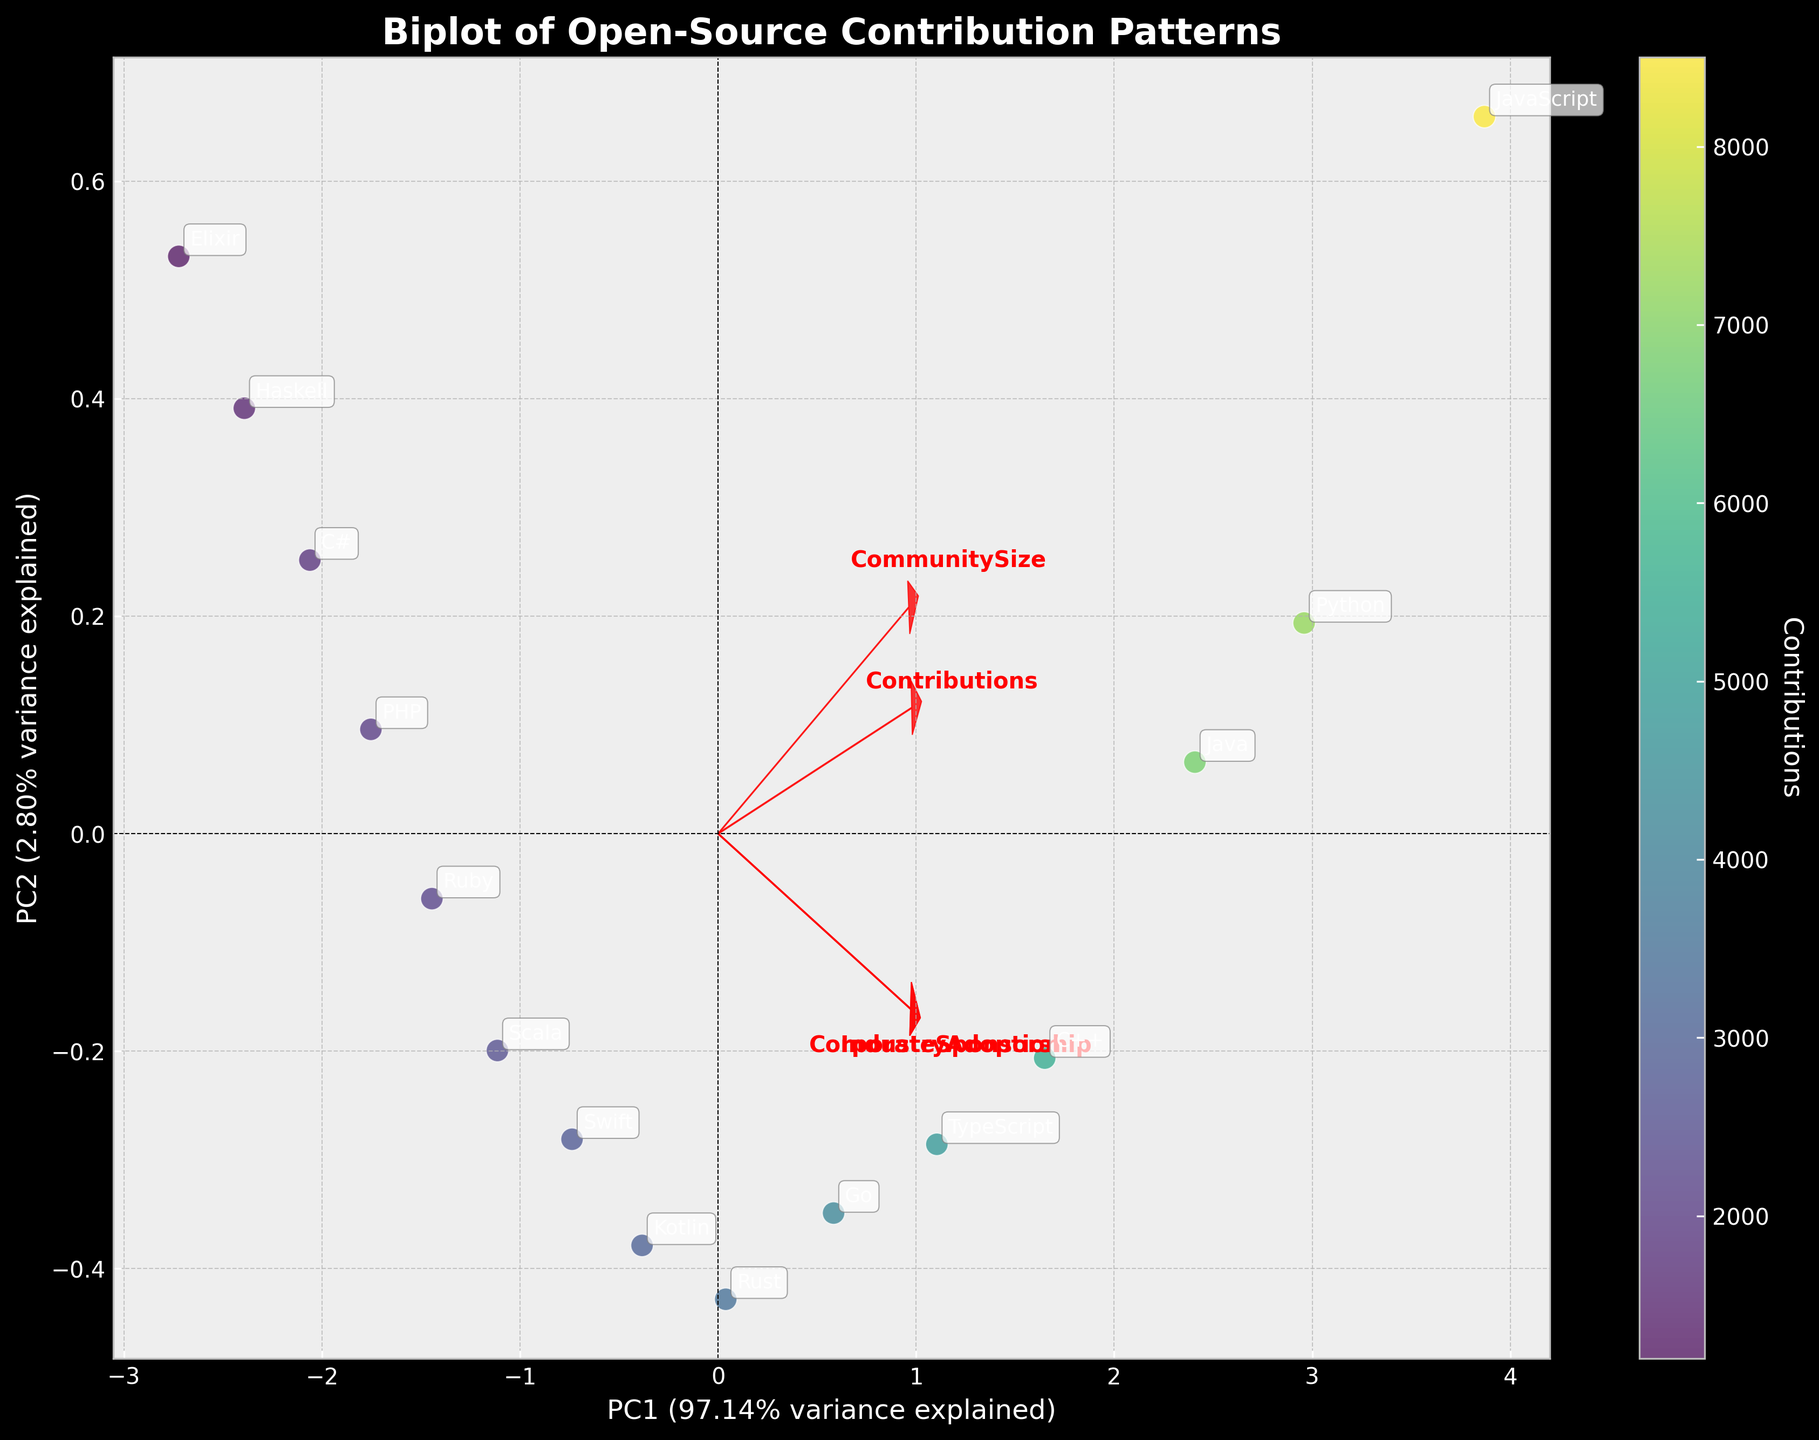What is the color gradient representing in the scatter plot? The color gradient represents the number of contributions made to open-source projects. Languages with higher contributions are indicated by different shades of a specific color on the scatter plot.
Answer: Contributions How are the principal components labeled on the axes? The x-axis is labeled as 'PC1' with the percentage of variance it explains, and the y-axis is labeled as 'PC2' with the percentage of variance it explains.
Answer: PC1 and PC2 Which language is positioned furthest to the right on the PC1 axis? By examining the scatter plot, the language positioned furthest to the right on the PC1 axis needs to be identified.
Answer: JavaScript Which feature has the largest vector along the PC1 axis? The feature with the largest vector along the PC1 axis is determined by the red arrows extending furthest in the x-direction.
Answer: Contributions What is the relationship between 'CommunitySize' and 'CorporateSponsorship' based on their vector orientation? By examining the orientation of the red arrows for 'CommunitySize' and 'CorporateSponsorship,' we can see if they point in similar or divergent directions, which shows their correlation.
Answer: Positive correlation Which programming language has contributions closer to the mean based on PCA analysis? By locating which data point is closest to the origin (0,0) on the PCA scatter plot, we can determine which language's contribution values are closer to the mean after normalization.
Answer: Kotlin Which two features are most similar in terms of their contribution to the principal components? Similarity between features can be identified by the red vectors that are closest to each other in direction and length.
Answer: CommunitySize and CorporateSponsorship Is the variance explained by PC1 greater or less than the variance explained by PC2? The x-axis (PC1) and y-axis (PC2) are labeled with their respective variance explained percentages, and comparing these percentages will provide the answer.
Answer: Greater Which language shows the lowest contributions, and where is it located on the biplot? By identifying the point with the lowest contribution in the color gradient and finding its corresponding label and location on the biplot.
Answer: Elixir, bottom left quadrant What can we infer about the 'IndustryAdoption' feature based on the biplot vectors? Evaluate the length and direction of the 'IndustryAdoption' vector to infer its influence and correlation with the principal components.
Answer: Strong influence, positively correlated with PC1 